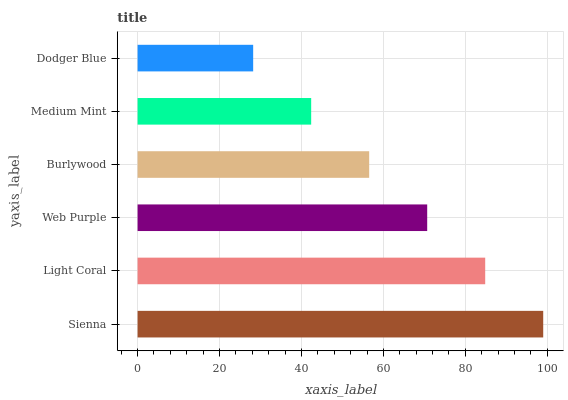Is Dodger Blue the minimum?
Answer yes or no. Yes. Is Sienna the maximum?
Answer yes or no. Yes. Is Light Coral the minimum?
Answer yes or no. No. Is Light Coral the maximum?
Answer yes or no. No. Is Sienna greater than Light Coral?
Answer yes or no. Yes. Is Light Coral less than Sienna?
Answer yes or no. Yes. Is Light Coral greater than Sienna?
Answer yes or no. No. Is Sienna less than Light Coral?
Answer yes or no. No. Is Web Purple the high median?
Answer yes or no. Yes. Is Burlywood the low median?
Answer yes or no. Yes. Is Sienna the high median?
Answer yes or no. No. Is Web Purple the low median?
Answer yes or no. No. 